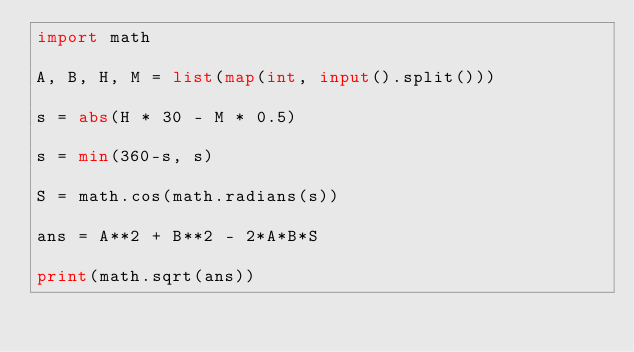Convert code to text. <code><loc_0><loc_0><loc_500><loc_500><_Python_>import math

A, B, H, M = list(map(int, input().split()))

s = abs(H * 30 - M * 0.5)

s = min(360-s, s)

S = math.cos(math.radians(s))

ans = A**2 + B**2 - 2*A*B*S

print(math.sqrt(ans))</code> 